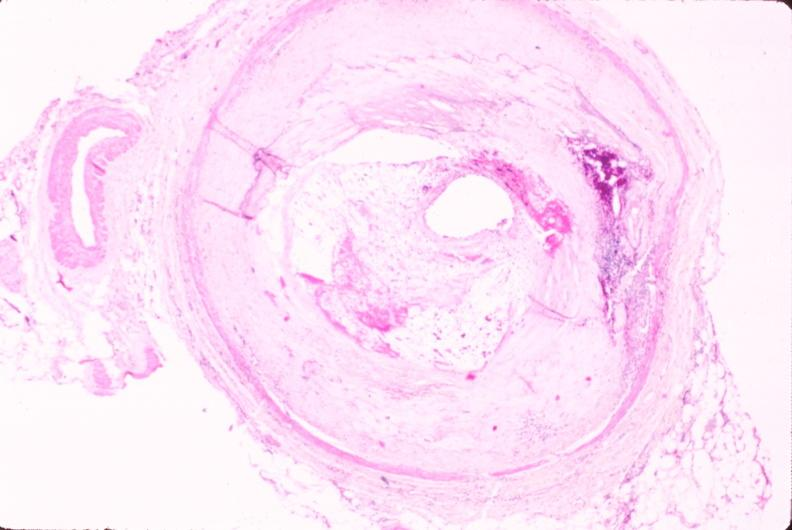what does this image show?
Answer the question using a single word or phrase. Atherosclerosis 